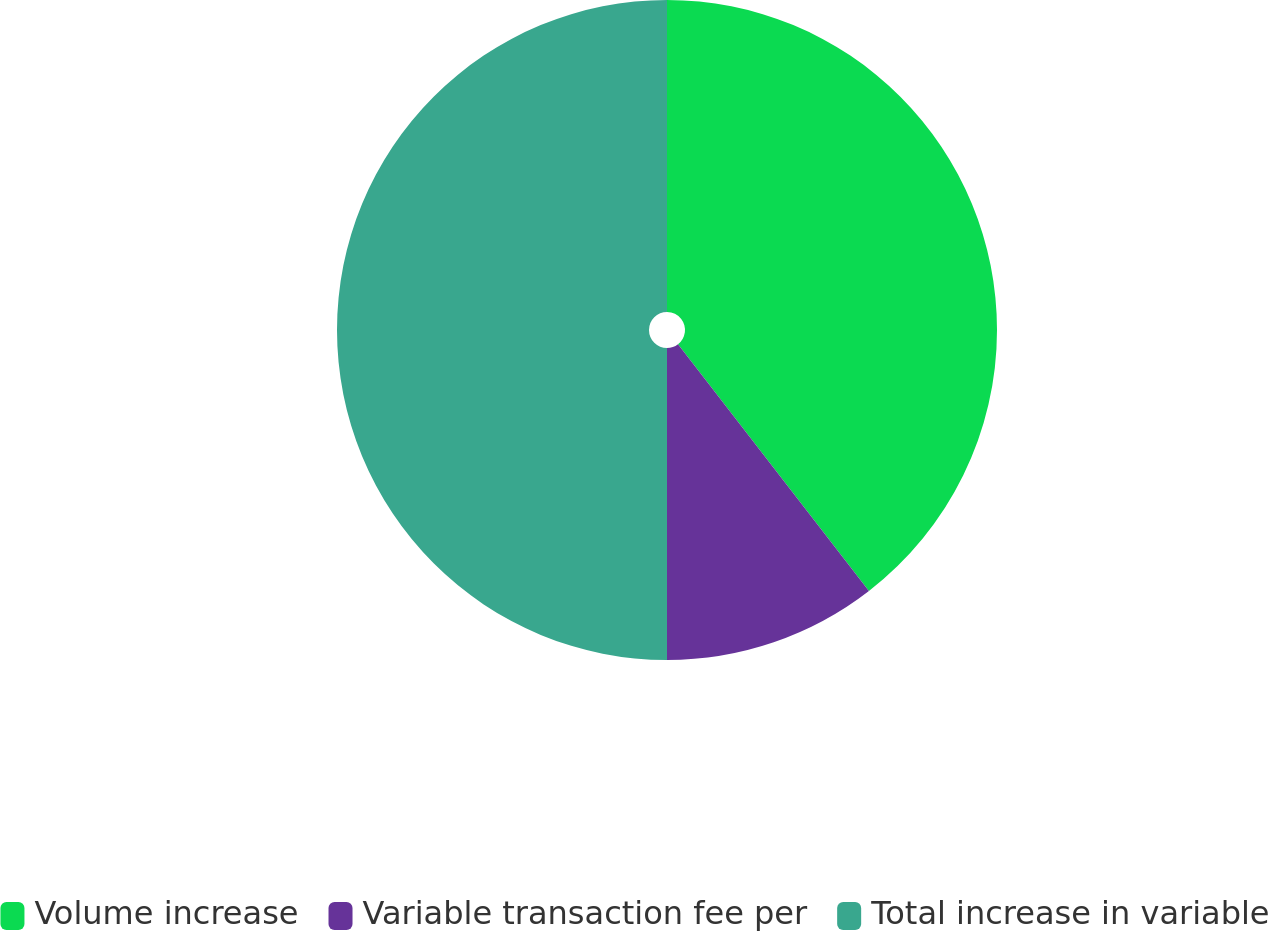Convert chart to OTSL. <chart><loc_0><loc_0><loc_500><loc_500><pie_chart><fcel>Volume increase<fcel>Variable transaction fee per<fcel>Total increase in variable<nl><fcel>39.52%<fcel>10.48%<fcel>50.0%<nl></chart> 